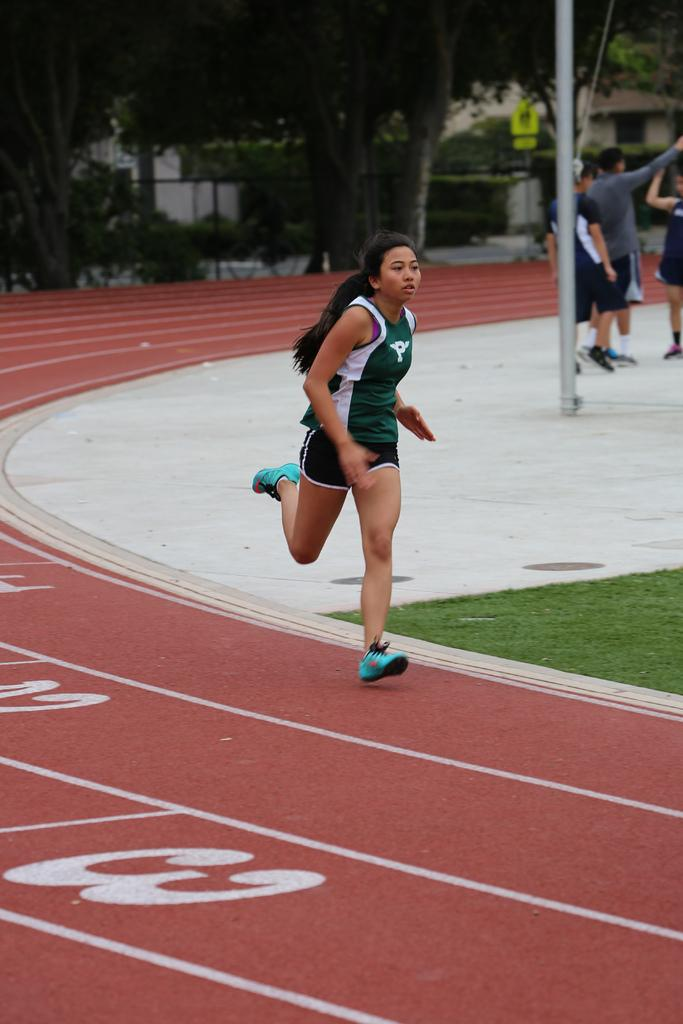<image>
Summarize the visual content of the image. A track athlete is running on a sport track with the numbers 1, 2, and 3 in each lane. 